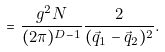Convert formula to latex. <formula><loc_0><loc_0><loc_500><loc_500>= \frac { g ^ { 2 } N } { ( 2 \pi ) ^ { D - 1 } } \frac { 2 } { ( { \vec { q } } _ { 1 } - { \vec { q } } _ { 2 } ) ^ { 2 } } .</formula> 